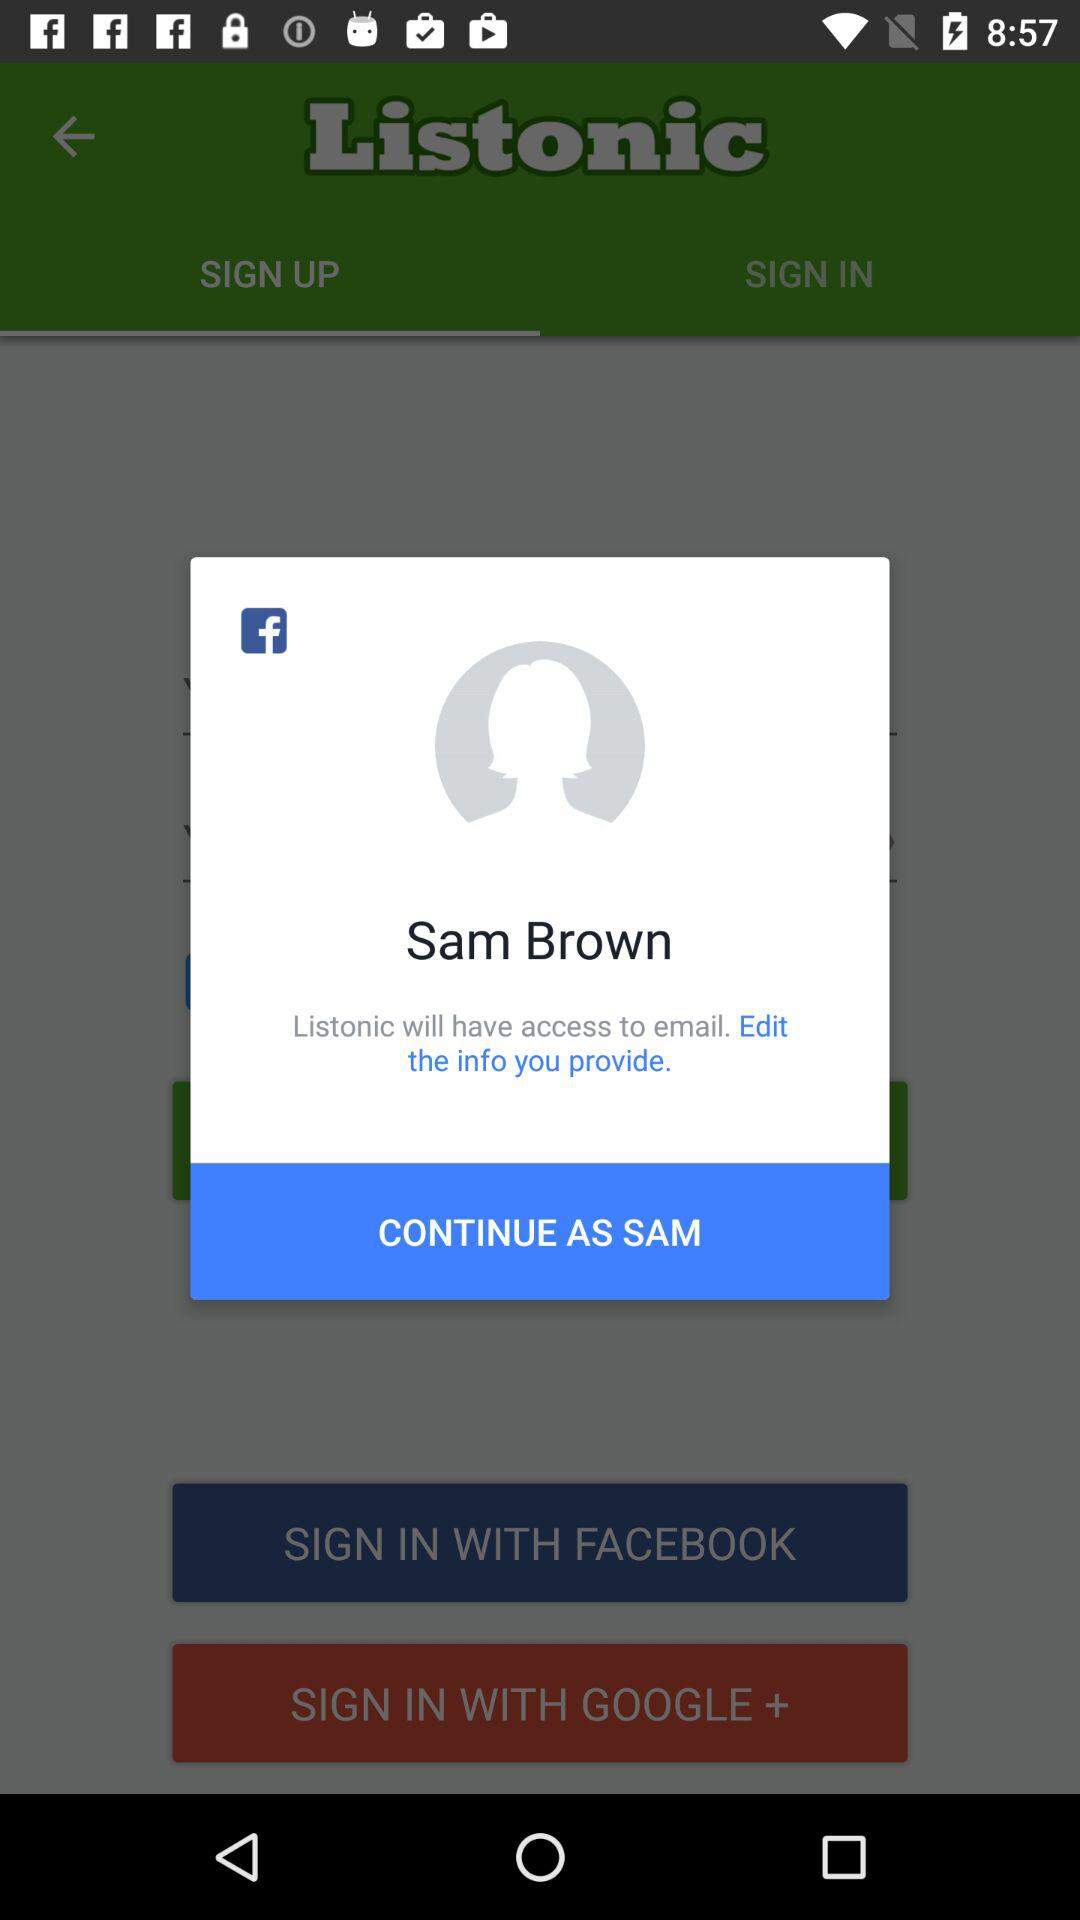What application is asking for permission? The application asking for permission is "Listonic". 